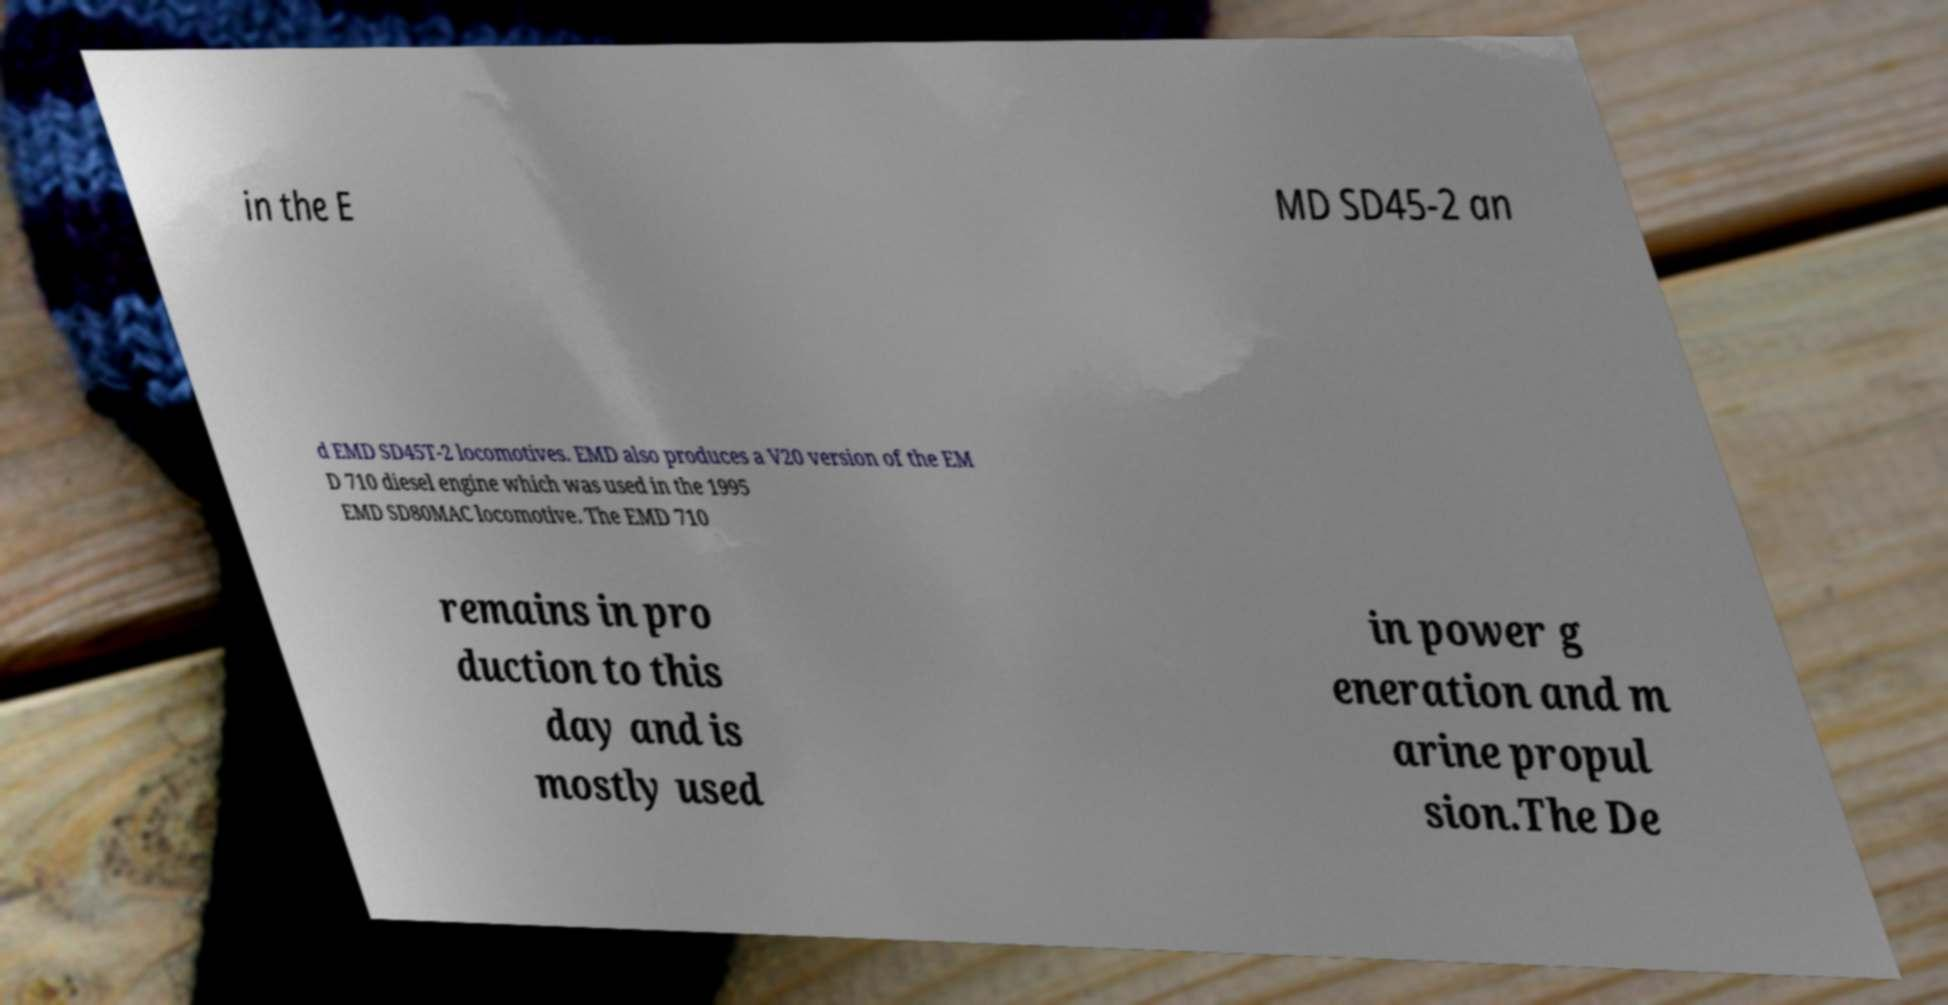I need the written content from this picture converted into text. Can you do that? in the E MD SD45-2 an d EMD SD45T-2 locomotives. EMD also produces a V20 version of the EM D 710 diesel engine which was used in the 1995 EMD SD80MAC locomotive. The EMD 710 remains in pro duction to this day and is mostly used in power g eneration and m arine propul sion.The De 